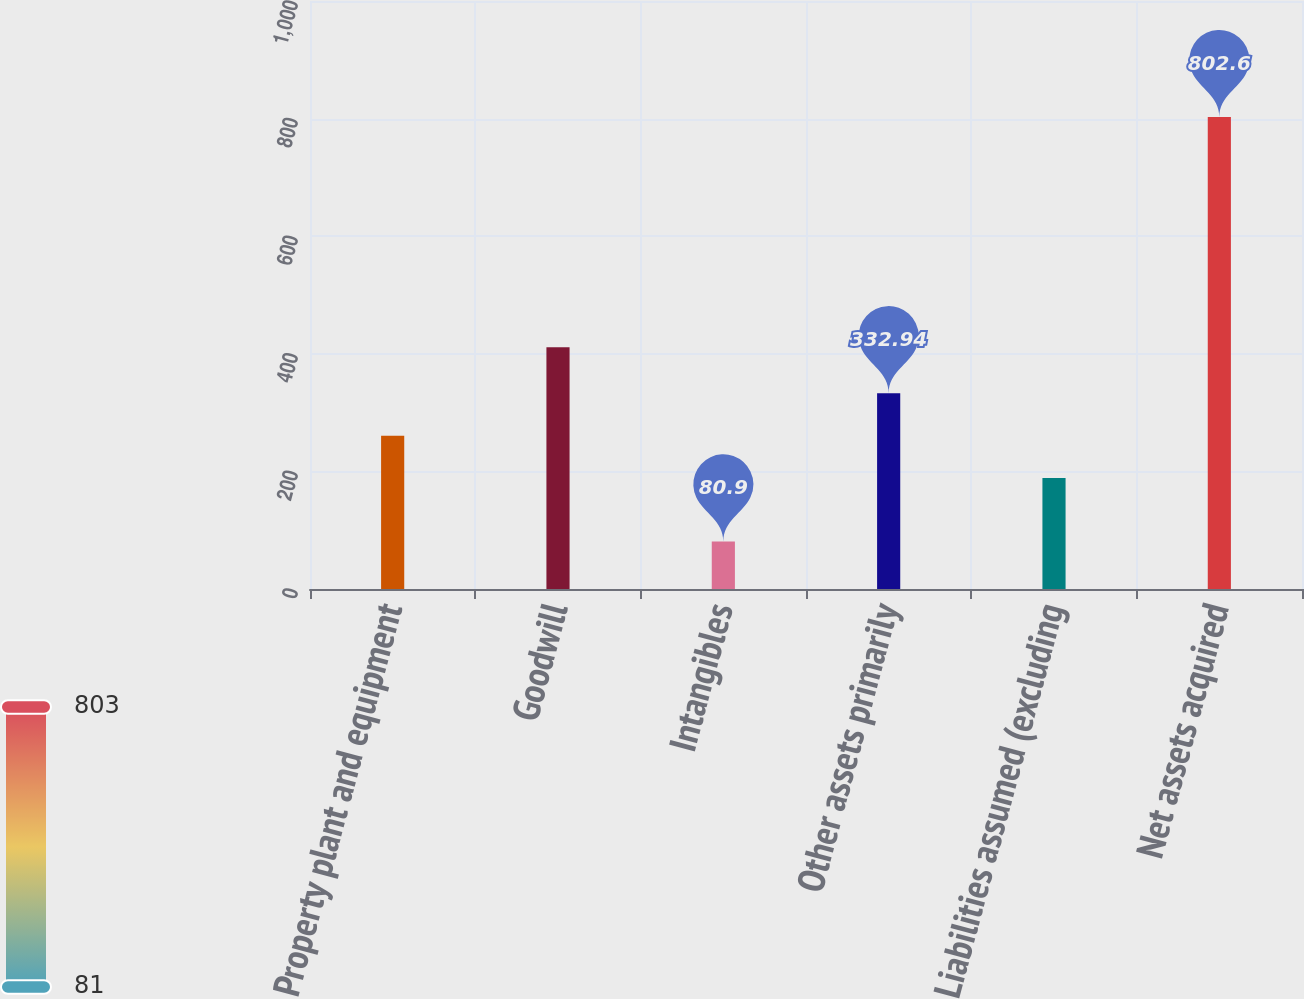<chart> <loc_0><loc_0><loc_500><loc_500><bar_chart><fcel>Property plant and equipment<fcel>Goodwill<fcel>Intangibles<fcel>Other assets primarily<fcel>Liabilities assumed (excluding<fcel>Net assets acquired<nl><fcel>260.77<fcel>411.1<fcel>80.9<fcel>332.94<fcel>188.6<fcel>802.6<nl></chart> 